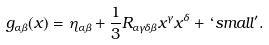Convert formula to latex. <formula><loc_0><loc_0><loc_500><loc_500>g _ { \alpha \beta } ( x ) = \eta _ { \alpha \beta } + \frac { 1 } { 3 } R _ { \alpha \gamma \delta \beta } x ^ { \gamma } x ^ { \delta } + ` s m a l l ^ { \prime } .</formula> 